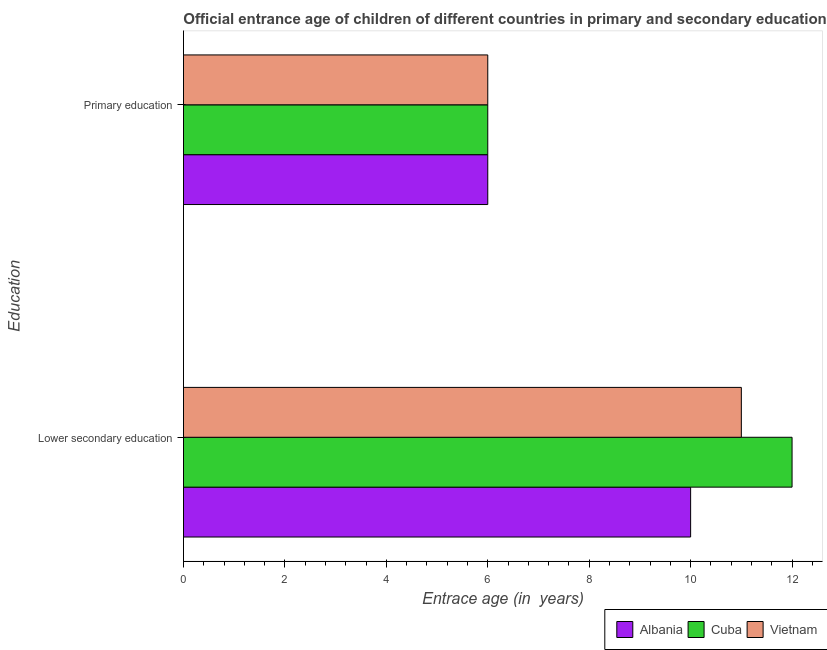How many different coloured bars are there?
Your response must be concise. 3. How many groups of bars are there?
Offer a very short reply. 2. How many bars are there on the 1st tick from the bottom?
Your response must be concise. 3. What is the label of the 1st group of bars from the top?
Keep it short and to the point. Primary education. What is the entrance age of chiildren in primary education in Vietnam?
Your response must be concise. 6. Across all countries, what is the maximum entrance age of chiildren in primary education?
Offer a terse response. 6. Across all countries, what is the minimum entrance age of children in lower secondary education?
Provide a short and direct response. 10. In which country was the entrance age of chiildren in primary education maximum?
Make the answer very short. Albania. In which country was the entrance age of chiildren in primary education minimum?
Your response must be concise. Albania. What is the total entrance age of children in lower secondary education in the graph?
Your response must be concise. 33. What is the difference between the entrance age of children in lower secondary education in Cuba and that in Albania?
Provide a short and direct response. 2. What is the difference between the entrance age of children in lower secondary education in Albania and the entrance age of chiildren in primary education in Cuba?
Give a very brief answer. 4. In how many countries, is the entrance age of chiildren in primary education greater than 2 years?
Offer a very short reply. 3. What is the ratio of the entrance age of children in lower secondary education in Albania to that in Cuba?
Your answer should be very brief. 0.83. Is the entrance age of children in lower secondary education in Vietnam less than that in Cuba?
Your answer should be compact. Yes. In how many countries, is the entrance age of children in lower secondary education greater than the average entrance age of children in lower secondary education taken over all countries?
Your answer should be compact. 1. What does the 1st bar from the top in Primary education represents?
Your answer should be compact. Vietnam. What does the 1st bar from the bottom in Primary education represents?
Ensure brevity in your answer.  Albania. How many bars are there?
Offer a very short reply. 6. Are all the bars in the graph horizontal?
Offer a very short reply. Yes. How many countries are there in the graph?
Your answer should be compact. 3. What is the difference between two consecutive major ticks on the X-axis?
Keep it short and to the point. 2. Are the values on the major ticks of X-axis written in scientific E-notation?
Make the answer very short. No. Does the graph contain grids?
Your answer should be compact. No. What is the title of the graph?
Ensure brevity in your answer.  Official entrance age of children of different countries in primary and secondary education. What is the label or title of the X-axis?
Make the answer very short. Entrace age (in  years). What is the label or title of the Y-axis?
Provide a short and direct response. Education. What is the Entrace age (in  years) of Albania in Primary education?
Provide a succinct answer. 6. What is the Entrace age (in  years) in Vietnam in Primary education?
Your answer should be very brief. 6. Across all Education, what is the maximum Entrace age (in  years) in Albania?
Your response must be concise. 10. Across all Education, what is the maximum Entrace age (in  years) in Cuba?
Make the answer very short. 12. Across all Education, what is the maximum Entrace age (in  years) of Vietnam?
Offer a very short reply. 11. Across all Education, what is the minimum Entrace age (in  years) in Albania?
Provide a succinct answer. 6. Across all Education, what is the minimum Entrace age (in  years) in Vietnam?
Keep it short and to the point. 6. What is the difference between the Entrace age (in  years) in Albania in Lower secondary education and that in Primary education?
Your answer should be compact. 4. What is the difference between the Entrace age (in  years) in Albania in Lower secondary education and the Entrace age (in  years) in Cuba in Primary education?
Give a very brief answer. 4. What is the difference between the Entrace age (in  years) of Albania in Lower secondary education and the Entrace age (in  years) of Vietnam in Primary education?
Your answer should be very brief. 4. What is the difference between the Entrace age (in  years) in Cuba in Lower secondary education and the Entrace age (in  years) in Vietnam in Primary education?
Give a very brief answer. 6. What is the average Entrace age (in  years) in Albania per Education?
Give a very brief answer. 8. What is the average Entrace age (in  years) of Cuba per Education?
Your answer should be compact. 9. What is the average Entrace age (in  years) of Vietnam per Education?
Provide a succinct answer. 8.5. What is the difference between the Entrace age (in  years) of Cuba and Entrace age (in  years) of Vietnam in Primary education?
Your response must be concise. 0. What is the ratio of the Entrace age (in  years) in Cuba in Lower secondary education to that in Primary education?
Provide a short and direct response. 2. What is the ratio of the Entrace age (in  years) of Vietnam in Lower secondary education to that in Primary education?
Offer a terse response. 1.83. What is the difference between the highest and the second highest Entrace age (in  years) in Vietnam?
Make the answer very short. 5. What is the difference between the highest and the lowest Entrace age (in  years) in Cuba?
Offer a terse response. 6. What is the difference between the highest and the lowest Entrace age (in  years) in Vietnam?
Your response must be concise. 5. 